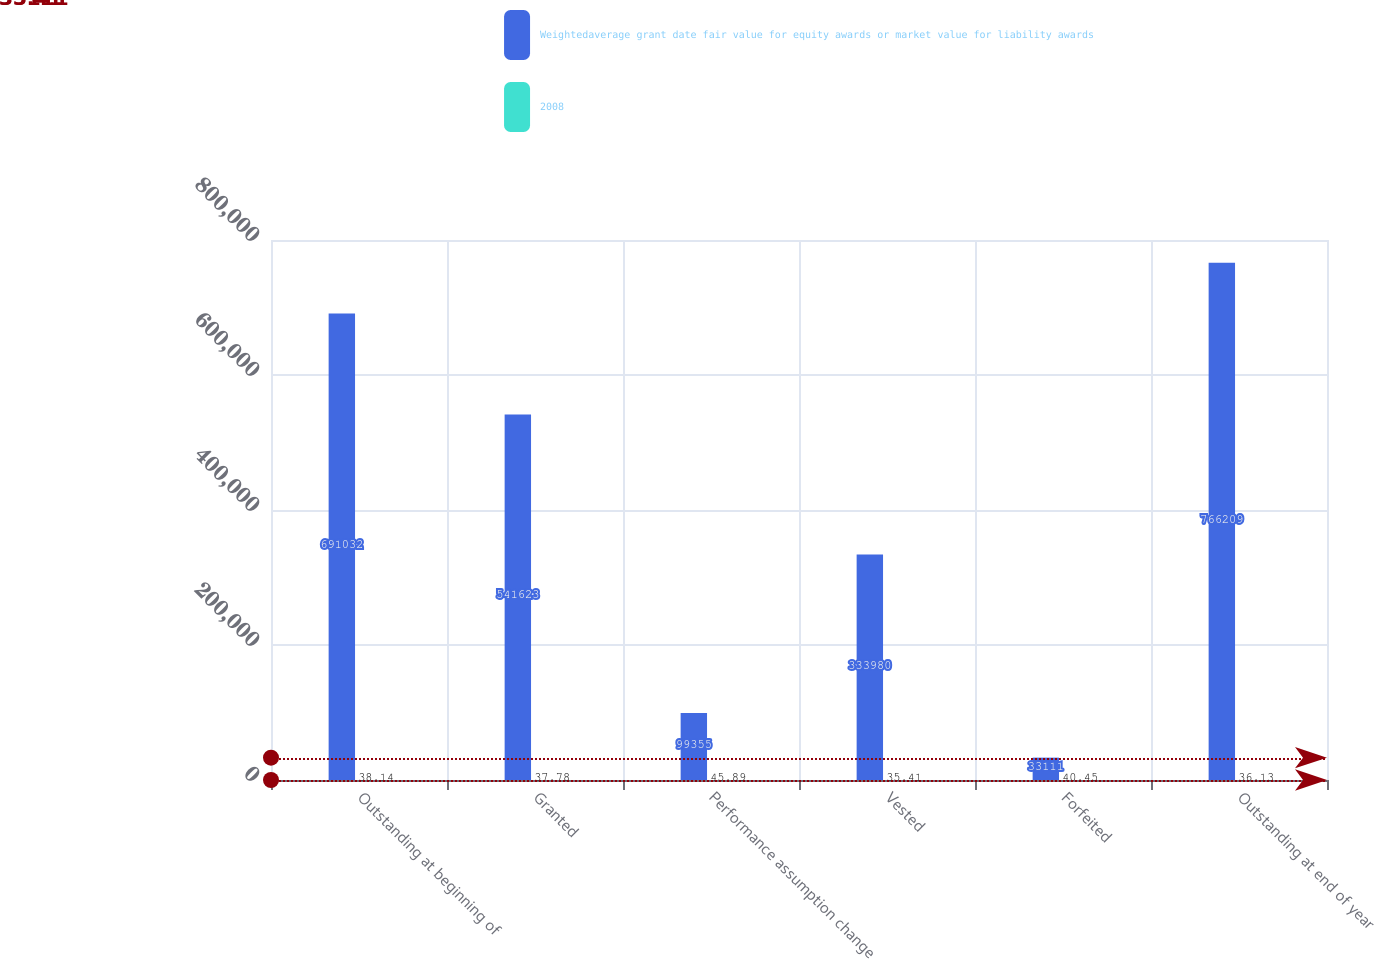<chart> <loc_0><loc_0><loc_500><loc_500><stacked_bar_chart><ecel><fcel>Outstanding at beginning of<fcel>Granted<fcel>Performance assumption change<fcel>Vested<fcel>Forfeited<fcel>Outstanding at end of year<nl><fcel>Weightedaverage grant date fair value for equity awards or market value for liability awards<fcel>691032<fcel>541623<fcel>99355<fcel>333980<fcel>33111<fcel>766209<nl><fcel>2008<fcel>38.14<fcel>37.78<fcel>45.89<fcel>35.41<fcel>40.45<fcel>36.13<nl></chart> 